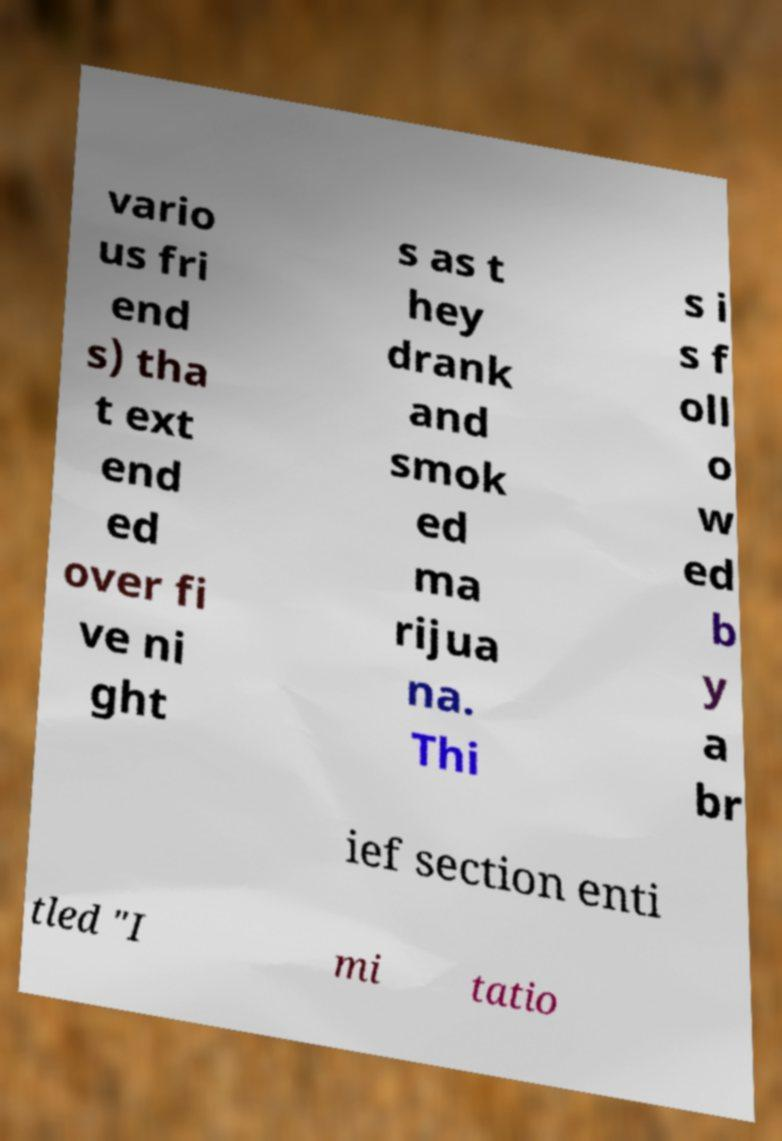Can you read and provide the text displayed in the image?This photo seems to have some interesting text. Can you extract and type it out for me? vario us fri end s) tha t ext end ed over fi ve ni ght s as t hey drank and smok ed ma rijua na. Thi s i s f oll o w ed b y a br ief section enti tled "I mi tatio 